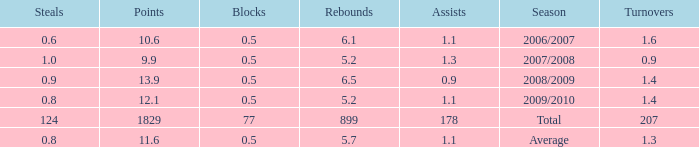How many blocks are there when the rebounds are fewer than 5.2? 0.0. 